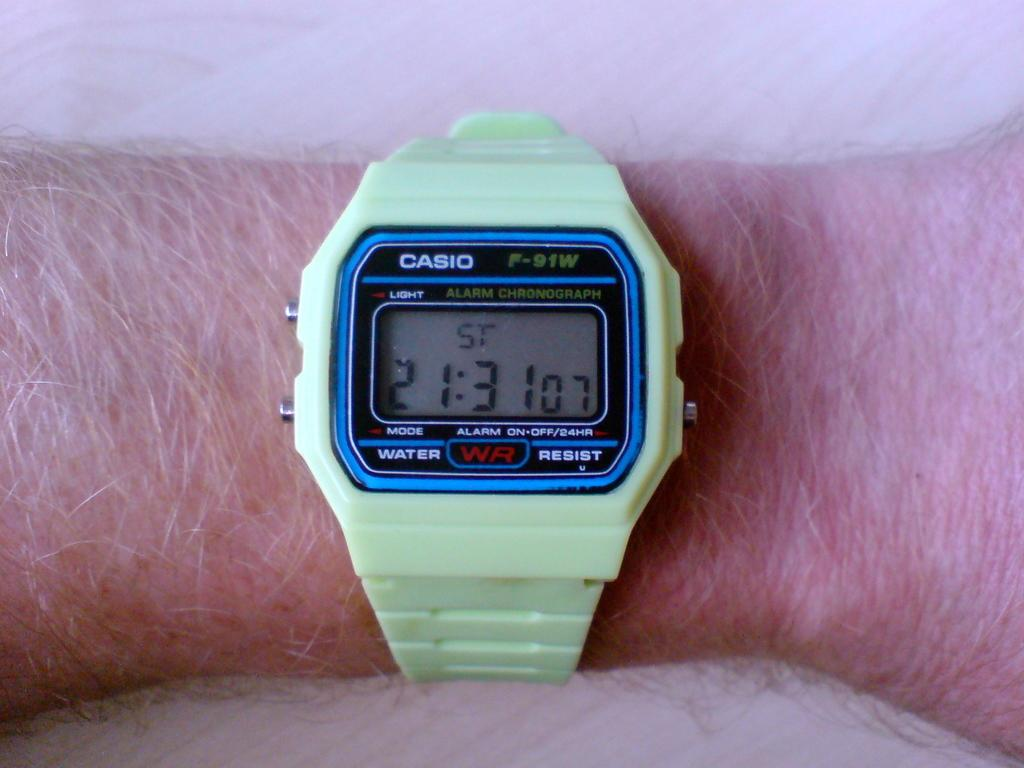<image>
Present a compact description of the photo's key features. a casio watch that is showing 21:31 no it 